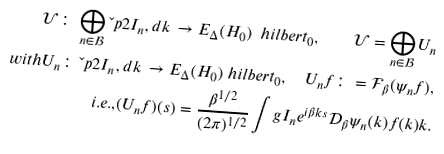Convert formula to latex. <formula><loc_0><loc_0><loc_500><loc_500>\mathcal { U } \colon \, \bigoplus _ { n \in \mathcal { B } } \L p { 2 } { I _ { n } , d k } \, \rightarrow E _ { \Delta } ( H _ { 0 } ) \ h i l b e r t _ { 0 } , \quad \mathcal { U } = \bigoplus _ { n \in \mathcal { B } } U _ { n } \\ { w i t h } U _ { n } \colon \, \L p { 2 } { I _ { n } , d k } \, \rightarrow E _ { \Delta } ( H _ { 0 } ) \ h i l b e r t _ { 0 } , \quad U _ { n } f \colon = \mathcal { F } _ { \beta } ( \psi _ { n } f ) , \\ { i . e . , } ( U _ { n } f ) ( s ) = \frac { \beta ^ { 1 / 2 } } { ( 2 \pi ) ^ { 1 / 2 } } \int g { I _ { n } } { e ^ { i \beta k s } \mathcal { D } _ { \beta } \psi _ { n } ( k ) f ( k ) } { k } .</formula> 